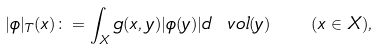Convert formula to latex. <formula><loc_0><loc_0><loc_500><loc_500>| \phi | _ { T } ( x ) \colon = \int _ { X } g ( x , y ) | \phi ( y ) | d \ v o l ( y ) \quad ( x \in X ) ,</formula> 